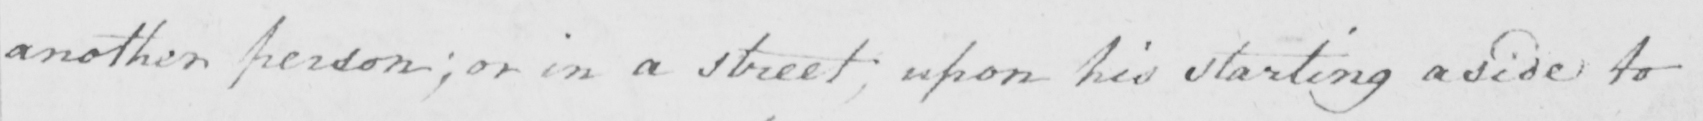What text is written in this handwritten line? another person ; or in a street upon his starting aside to 